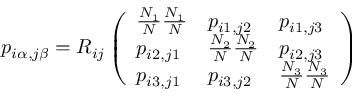Convert formula to latex. <formula><loc_0><loc_0><loc_500><loc_500>p _ { i \alpha , j \beta } = R _ { i j } \left ( \begin{array} { l l l } { \frac { N _ { 1 } } { N } \frac { N _ { 1 } } { N } } & { p _ { i 1 , j 2 } } & { p _ { i 1 , j 3 } } \\ { p _ { i 2 , j 1 } } & { \frac { N _ { 2 } } { N } \frac { N _ { 2 } } { N } } & { p _ { i 2 , j 3 } } \\ { p _ { i 3 , j 1 } } & { p _ { i 3 , j 2 } } & { \frac { N _ { 3 } } { N } \frac { N _ { 3 } } { N } } \end{array} \right )</formula> 